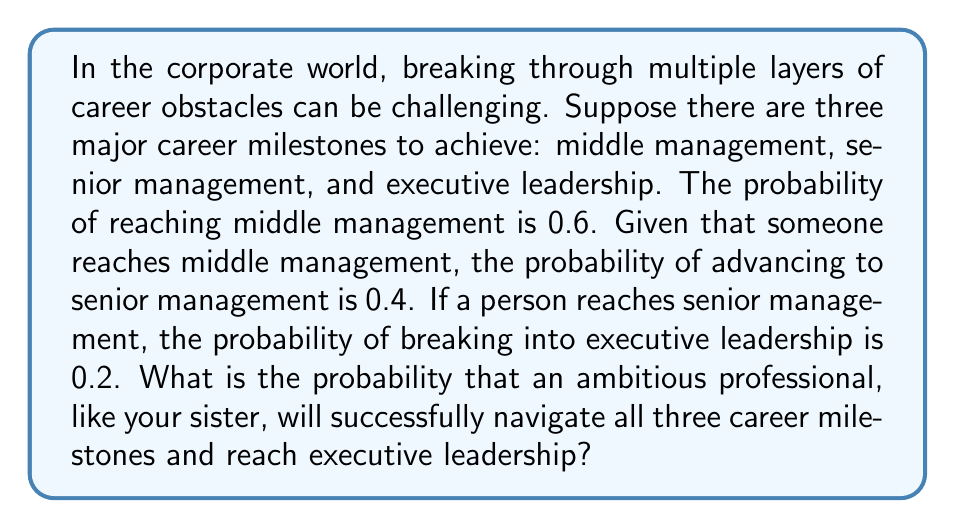Can you solve this math problem? To solve this problem, we'll use the concept of conditional probability and the multiplication rule for dependent events.

Step 1: Define the events
Let M = reaching middle management
Let S = reaching senior management
Let E = reaching executive leadership

Step 2: Given probabilities
P(M) = 0.6
P(S|M) = 0.4 (probability of S given M)
P(E|S) = 0.2 (probability of E given S)

Step 3: Use the multiplication rule for dependent events
The probability of all three events occurring is:

$$P(M \cap S \cap E) = P(M) \cdot P(S|M) \cdot P(E|S)$$

Step 4: Substitute the given probabilities
$$P(M \cap S \cap E) = 0.6 \cdot 0.4 \cdot 0.2$$

Step 5: Calculate the final probability
$$P(M \cap S \cap E) = 0.6 \cdot 0.4 \cdot 0.2 = 0.048$$

Therefore, the probability of successfully navigating all three career milestones and reaching executive leadership is 0.048 or 4.8%.
Answer: 0.048 